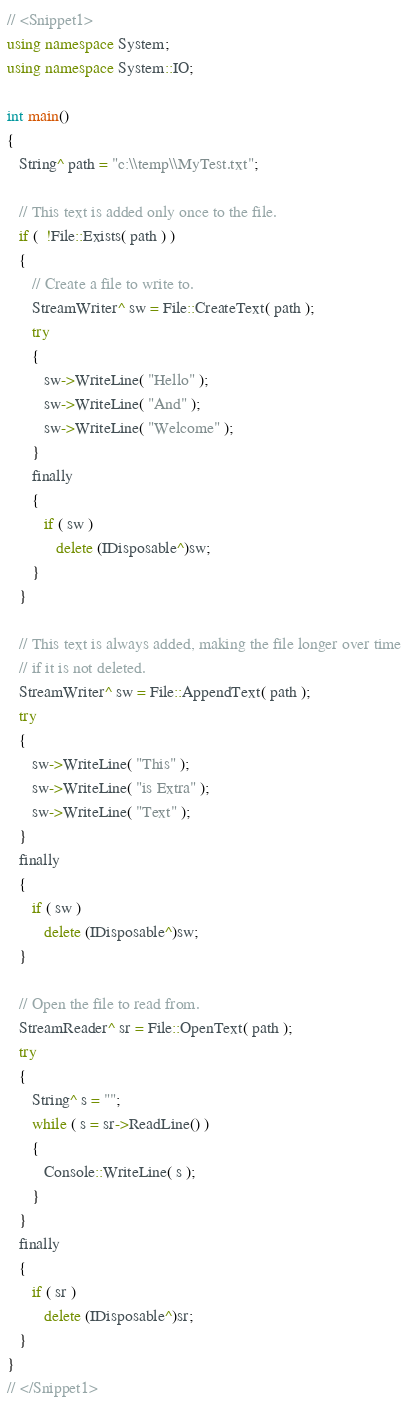<code> <loc_0><loc_0><loc_500><loc_500><_C++_>// <Snippet1>
using namespace System;
using namespace System::IO;

int main()
{
   String^ path = "c:\\temp\\MyTest.txt";
   
   // This text is added only once to the file.
   if (  !File::Exists( path ) )
   {
      // Create a file to write to.
      StreamWriter^ sw = File::CreateText( path );
      try
      {
         sw->WriteLine( "Hello" );
         sw->WriteLine( "And" );
         sw->WriteLine( "Welcome" );
      }
      finally
      {
         if ( sw )
            delete (IDisposable^)sw;
      }
   }
   
   // This text is always added, making the file longer over time
   // if it is not deleted.
   StreamWriter^ sw = File::AppendText( path );
   try
   {
      sw->WriteLine( "This" );
      sw->WriteLine( "is Extra" );
      sw->WriteLine( "Text" );
   }
   finally
   {
      if ( sw )
         delete (IDisposable^)sw;
   }
   
   // Open the file to read from.
   StreamReader^ sr = File::OpenText( path );
   try
   {
      String^ s = "";
      while ( s = sr->ReadLine() )
      {
         Console::WriteLine( s );
      }
   }
   finally
   {
      if ( sr )
         delete (IDisposable^)sr;
   }
}
// </Snippet1>
</code> 